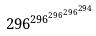<formula> <loc_0><loc_0><loc_500><loc_500>2 9 6 ^ { 2 9 6 ^ { 2 9 6 ^ { 2 9 6 ^ { 2 9 4 } } } }</formula> 